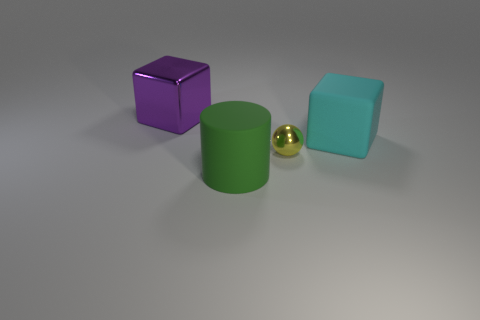How would the lighting in this scene affect the appearance of the objects if it were changed? If the lighting in this scene were to be altered, it would significantly affect the appearance of all the objects. Enhanced or dimmed lighting could change the intensity of the shadows and the way the objects' materials reflect light. Directional changes would also alter the location and length of the shadows, creating a different mood and visual dynamic in the scene. 